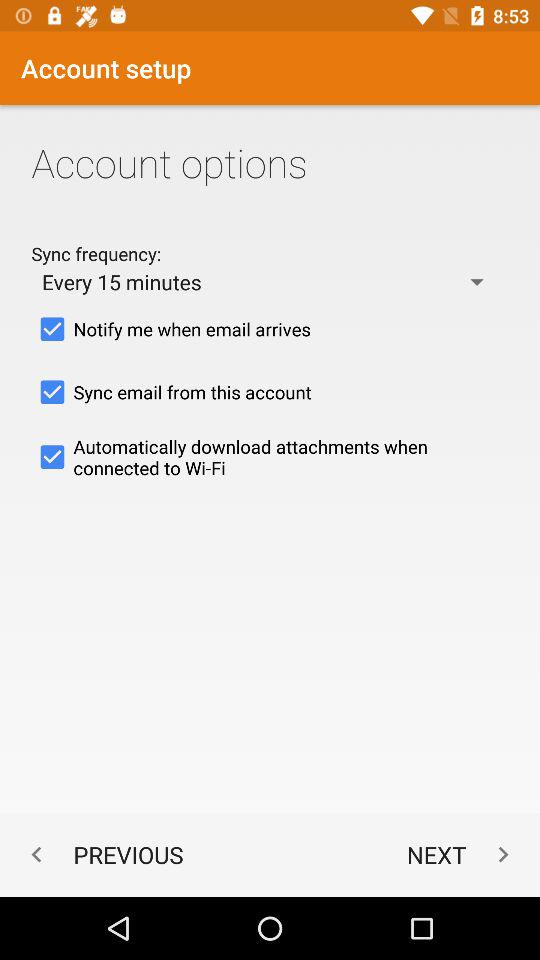How often does the sync repeat? Sync repeats every 15 minutes. 